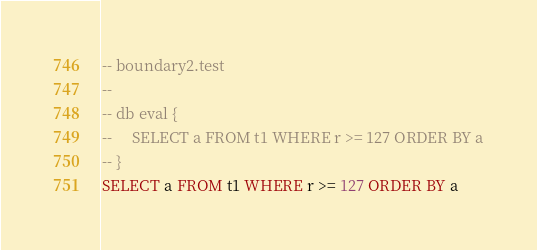Convert code to text. <code><loc_0><loc_0><loc_500><loc_500><_SQL_>-- boundary2.test
-- 
-- db eval {
--     SELECT a FROM t1 WHERE r >= 127 ORDER BY a
-- }
SELECT a FROM t1 WHERE r >= 127 ORDER BY a</code> 